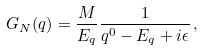Convert formula to latex. <formula><loc_0><loc_0><loc_500><loc_500>G _ { N } ( q ) = \frac { M } { E _ { q } } \frac { 1 } { q ^ { 0 } - E _ { q } + i \epsilon } \, ,</formula> 